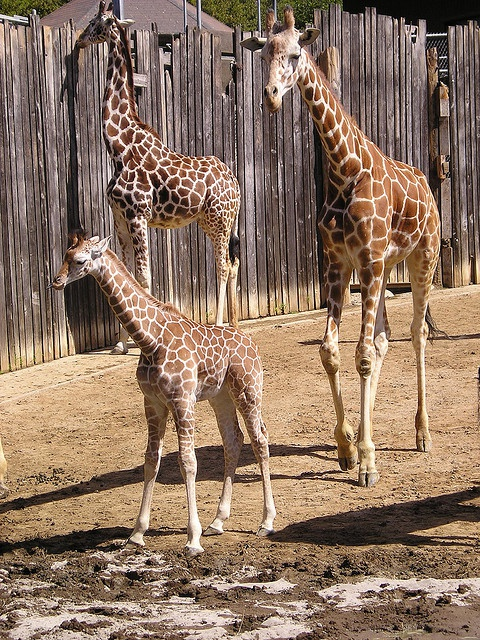Describe the objects in this image and their specific colors. I can see giraffe in darkgreen, gray, maroon, black, and ivory tones, giraffe in darkgreen, white, gray, tan, and maroon tones, and giraffe in darkgreen, black, gray, white, and maroon tones in this image. 